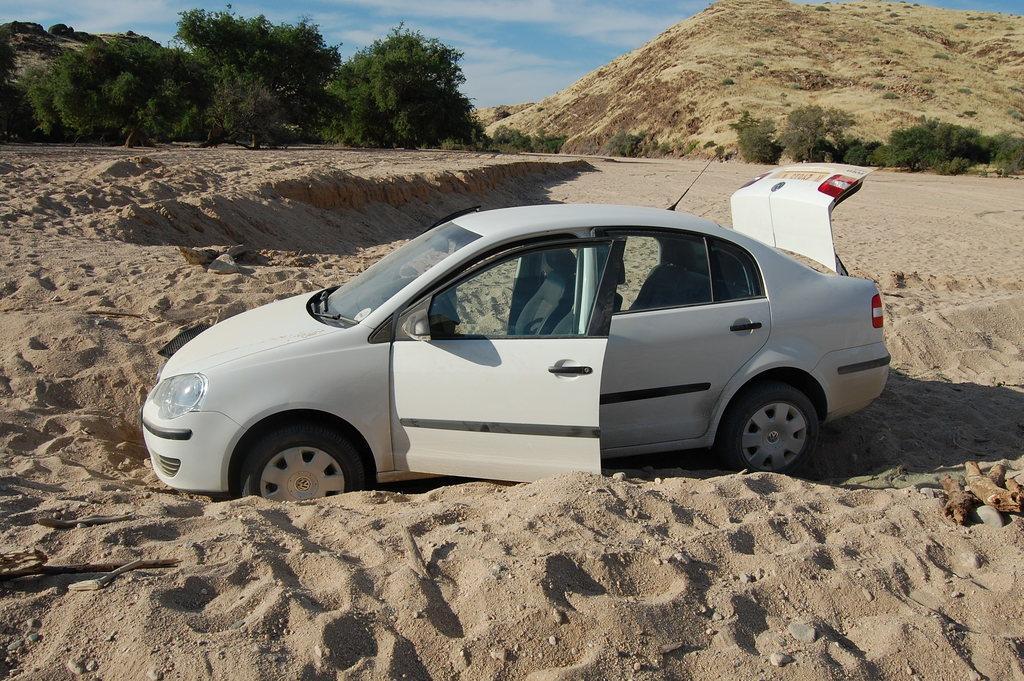In one or two sentences, can you explain what this image depicts? This picture shows a white car and we see trees and a Hill. We see front doors and trunk of a car is opened and we see a blue cloudy sky. 